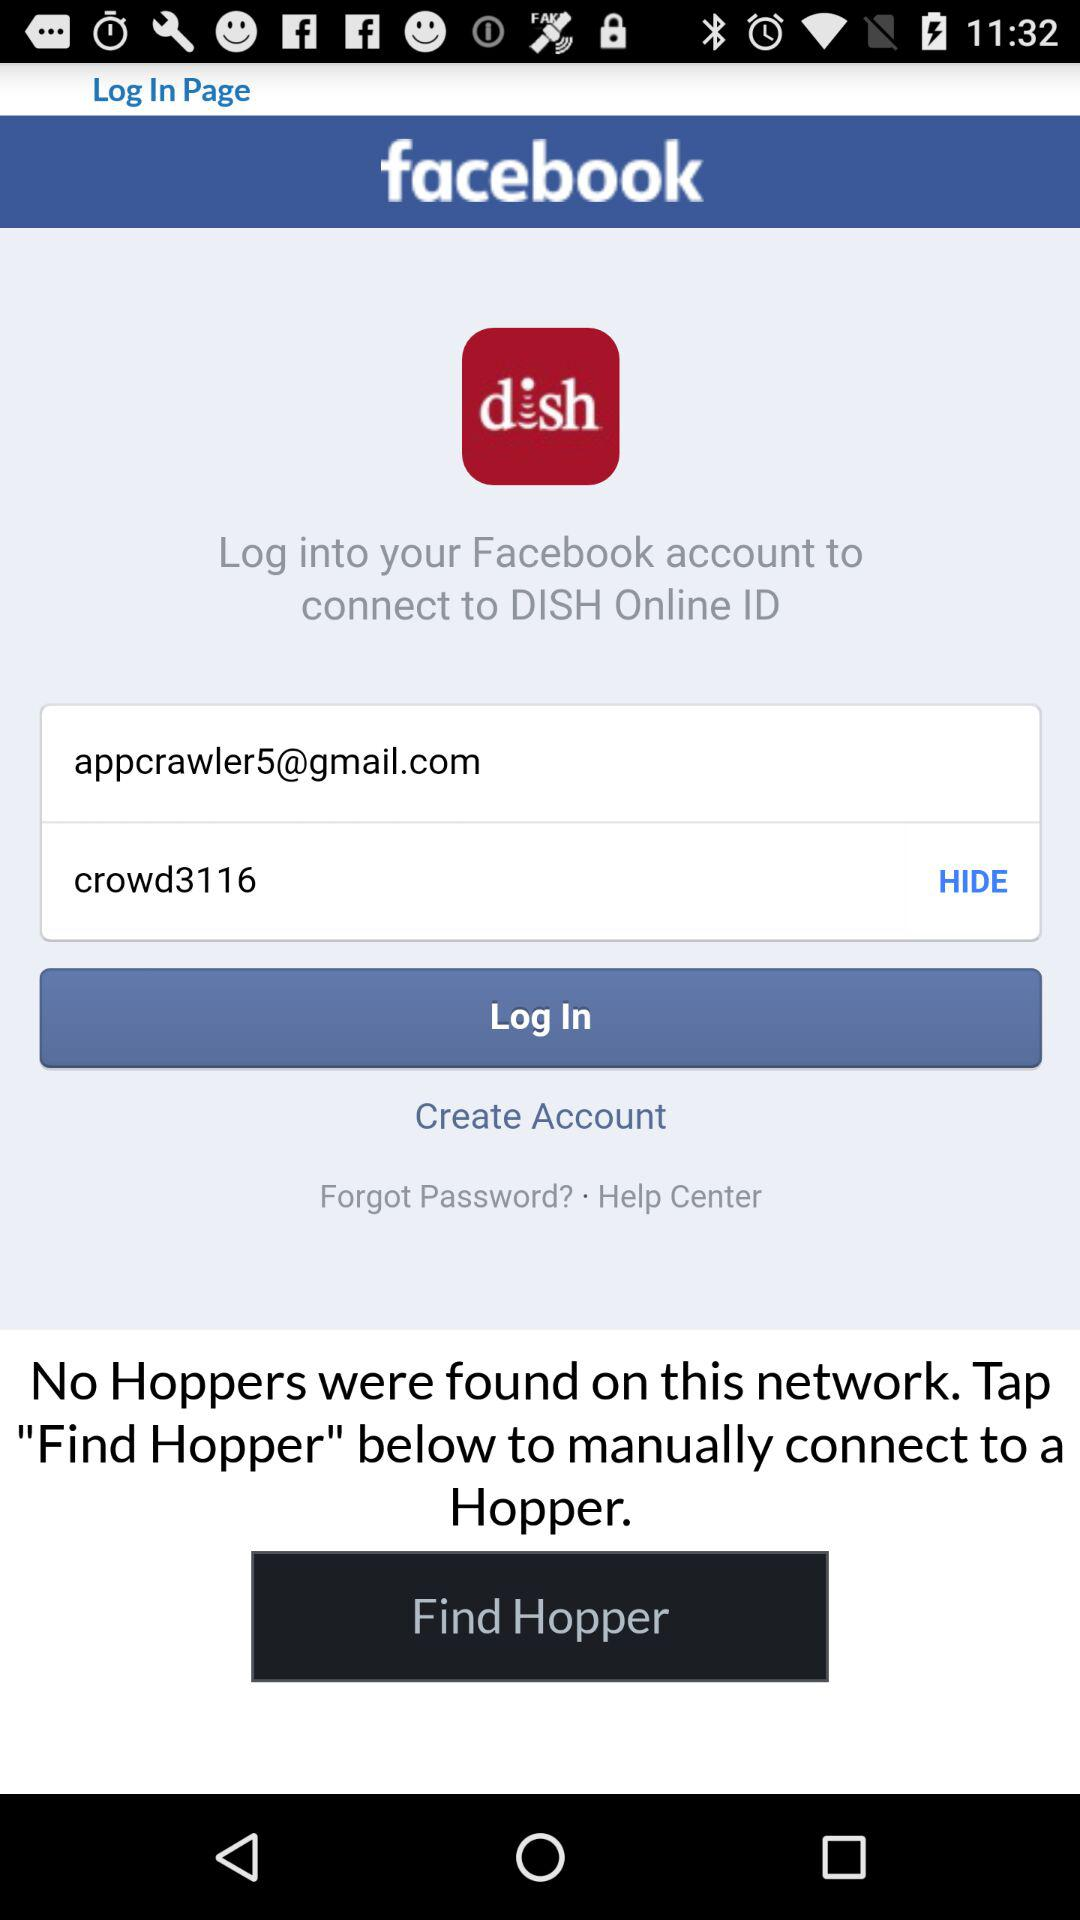Through which application can we log in to connect to "DISH Online ID"? You can log in to "Facebook" to connect to "DISH Online ID". 